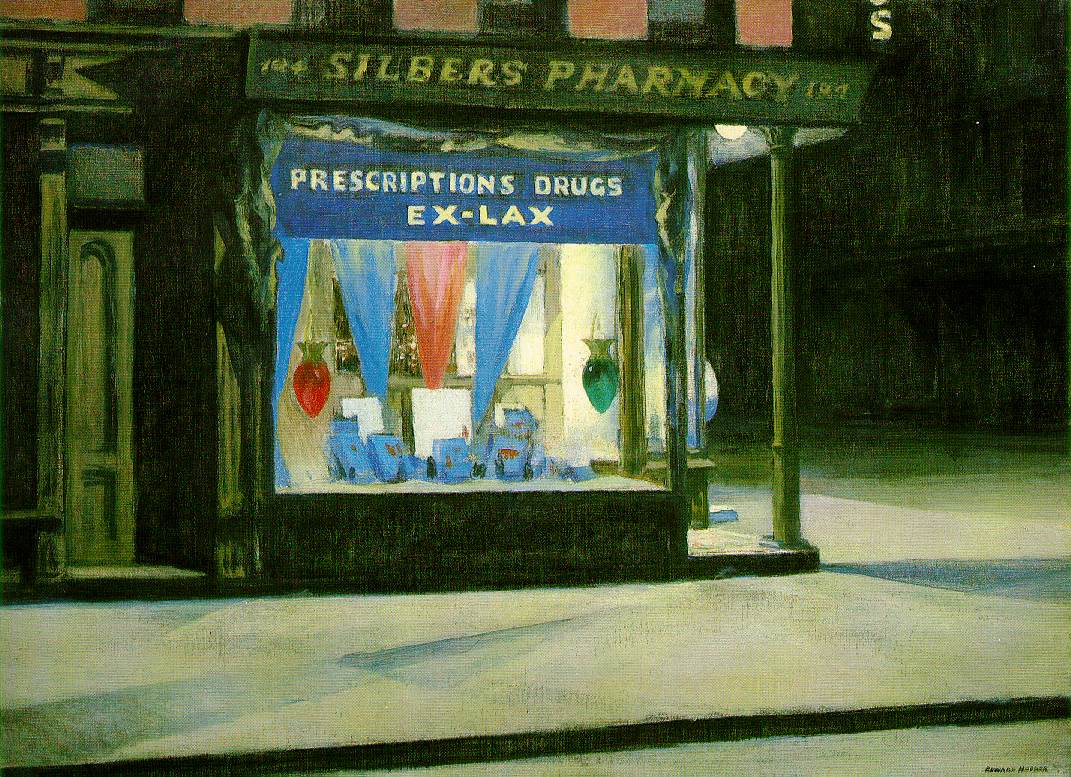Describe the following image. The image illustrates a nighttime urban setting, specifically highlighting the exterior of a pharmacy known as "Silber's Pharmacy". This is represented in an American realism style painting, which is renowned for its meticulous and straightforward portrayal of day-to-day life. 

The scene is dark and muted, contributing to a solemn and hushed ambiance typical of a city street during nighttime. However, the pharmacy's window display introduces a contrasting brightness with its vivid blue and red tones.

Above the window, a sign reads "Prescriptions Drugs Ex-Lax", revealing the store's purpose. The window is adorned with various bottles and boxes of medicine, further underscoring the building's function. Despite the lively colors of the display, the street is empty, enhancing the overall quiet and melancholic spirit of the painting.

This painting captures a common urban scene but stands out due to its intricate details and the intricate play of light and shadow, which instills a sense of mystery and depth. It portrays a typical moment of everyday life while inviting the viewer to imagine potential stories arising from this setting. 